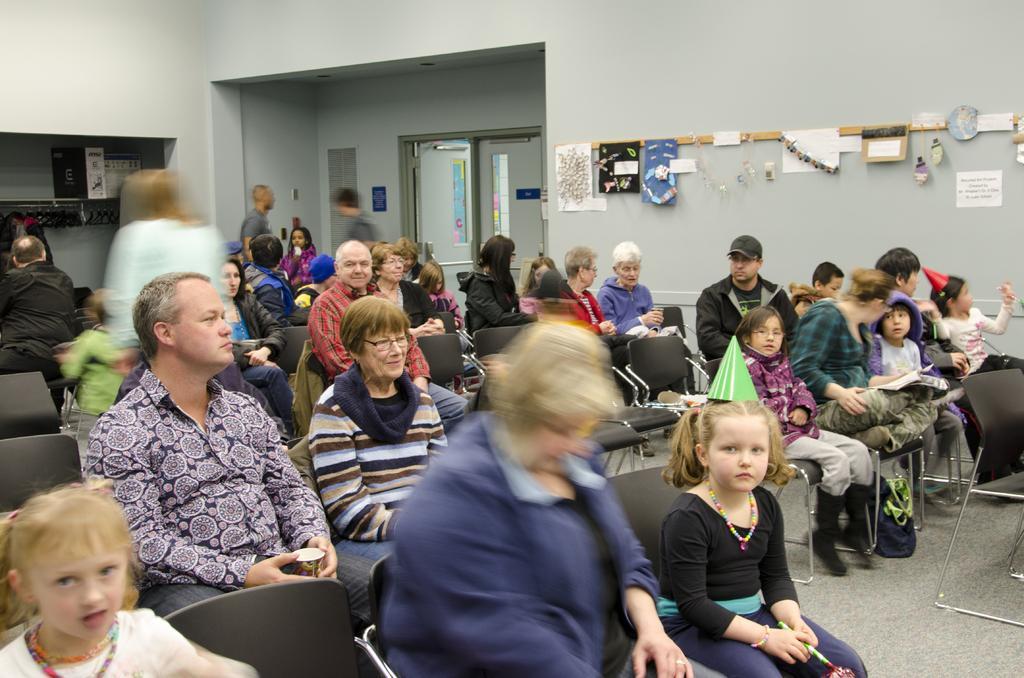Describe this image in one or two sentences. In this image I see number of people and most of them are sitting on chairs and few of them are standing, In the background I see the wall and there are papers and art on the wall and I see the doors over here. 